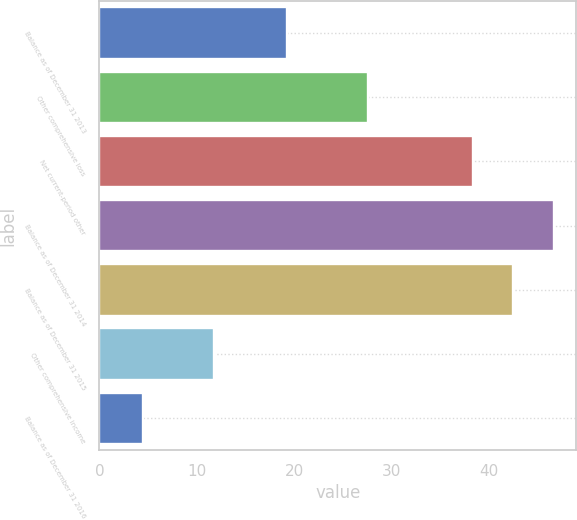Convert chart. <chart><loc_0><loc_0><loc_500><loc_500><bar_chart><fcel>Balance as of December 31 2013<fcel>Other comprehensive loss<fcel>Net current-period other<fcel>Balance as of December 31 2014<fcel>Balance as of December 31 2015<fcel>Other comprehensive income<fcel>Balance as of December 31 2016<nl><fcel>19.3<fcel>27.62<fcel>38.3<fcel>46.62<fcel>42.46<fcel>11.8<fcel>4.46<nl></chart> 